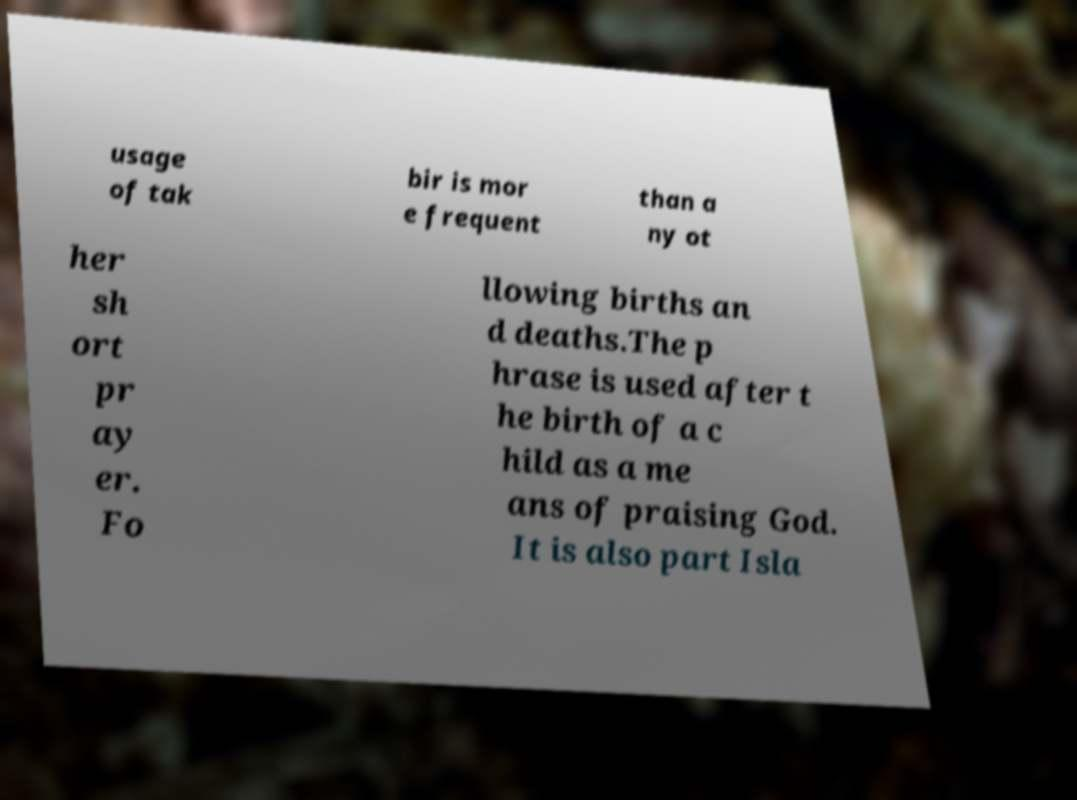Please identify and transcribe the text found in this image. usage of tak bir is mor e frequent than a ny ot her sh ort pr ay er. Fo llowing births an d deaths.The p hrase is used after t he birth of a c hild as a me ans of praising God. It is also part Isla 